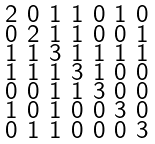<formula> <loc_0><loc_0><loc_500><loc_500>\begin{smallmatrix} 2 & 0 & 1 & 1 & 0 & 1 & 0 \\ 0 & 2 & 1 & 1 & 0 & 0 & 1 \\ 1 & 1 & 3 & 1 & 1 & 1 & 1 \\ 1 & 1 & 1 & 3 & 1 & 0 & 0 \\ 0 & 0 & 1 & 1 & 3 & 0 & 0 \\ 1 & 0 & 1 & 0 & 0 & 3 & 0 \\ 0 & 1 & 1 & 0 & 0 & 0 & 3 \end{smallmatrix}</formula> 